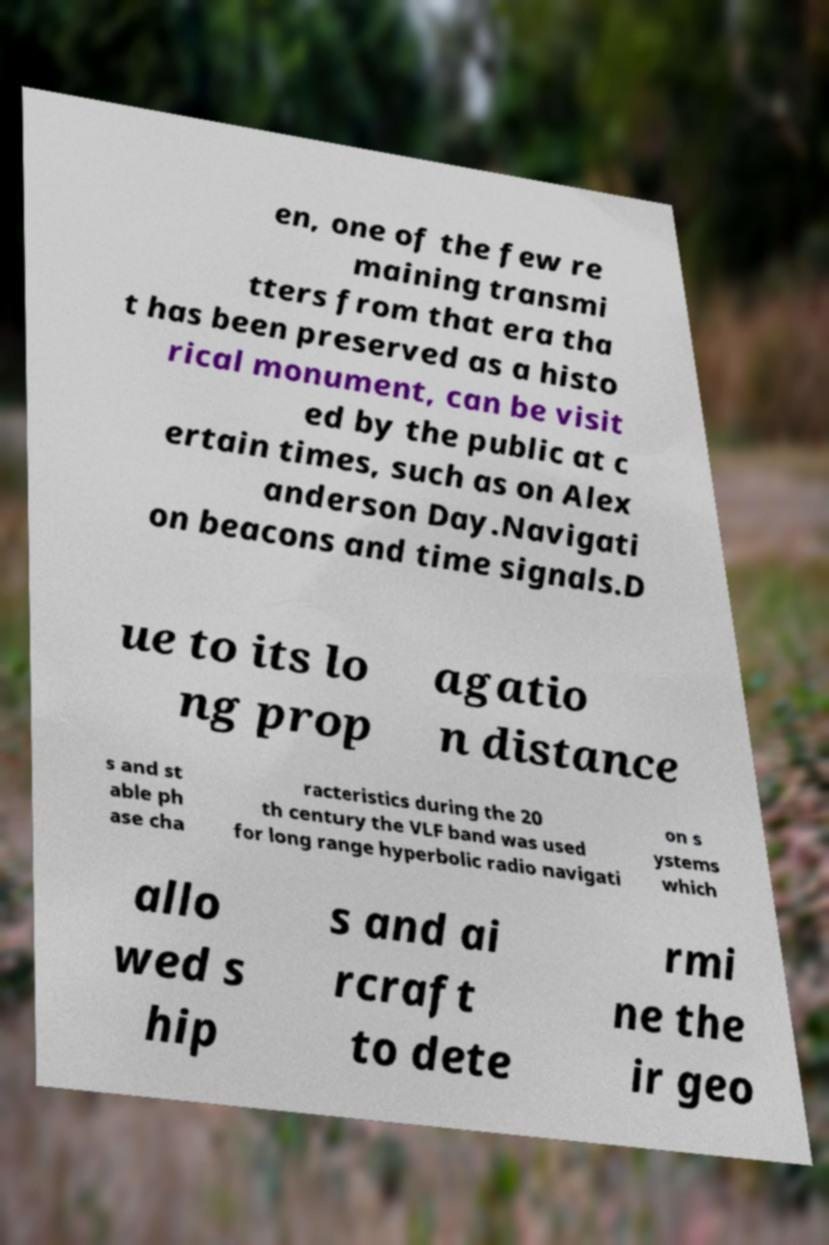For documentation purposes, I need the text within this image transcribed. Could you provide that? en, one of the few re maining transmi tters from that era tha t has been preserved as a histo rical monument, can be visit ed by the public at c ertain times, such as on Alex anderson Day.Navigati on beacons and time signals.D ue to its lo ng prop agatio n distance s and st able ph ase cha racteristics during the 20 th century the VLF band was used for long range hyperbolic radio navigati on s ystems which allo wed s hip s and ai rcraft to dete rmi ne the ir geo 